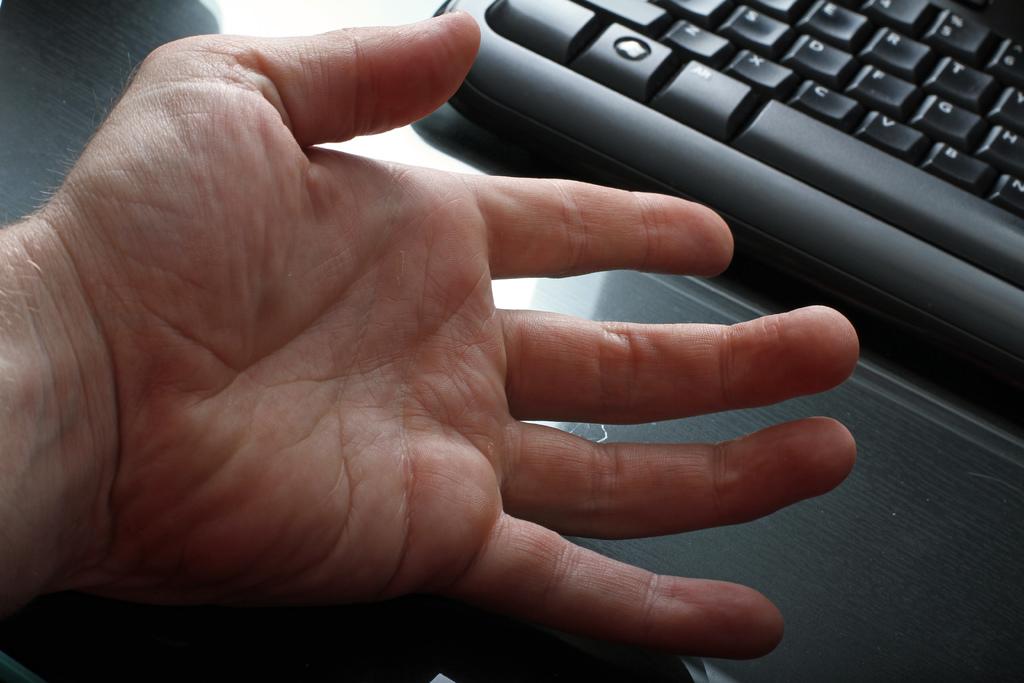What are the 3 buttons just above the spacebar?
Provide a short and direct response. Cvb. 